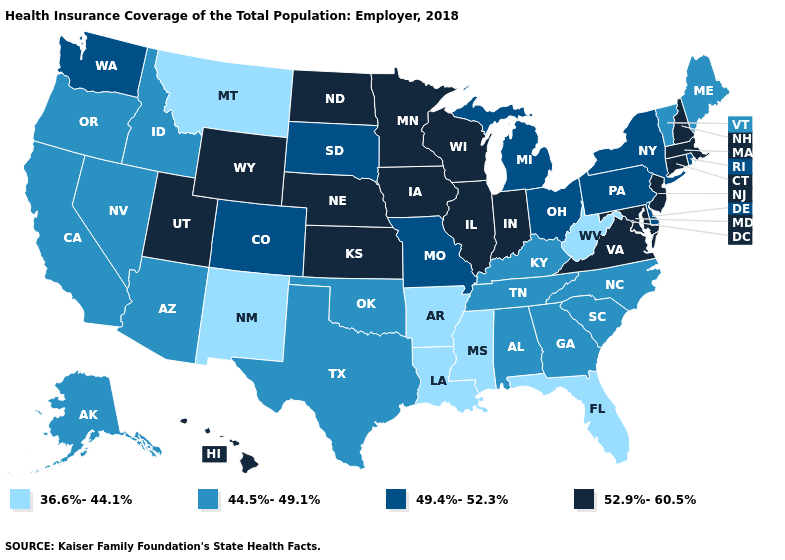Name the states that have a value in the range 52.9%-60.5%?
Short answer required. Connecticut, Hawaii, Illinois, Indiana, Iowa, Kansas, Maryland, Massachusetts, Minnesota, Nebraska, New Hampshire, New Jersey, North Dakota, Utah, Virginia, Wisconsin, Wyoming. Name the states that have a value in the range 49.4%-52.3%?
Give a very brief answer. Colorado, Delaware, Michigan, Missouri, New York, Ohio, Pennsylvania, Rhode Island, South Dakota, Washington. What is the lowest value in the USA?
Concise answer only. 36.6%-44.1%. Does the first symbol in the legend represent the smallest category?
Quick response, please. Yes. Which states have the highest value in the USA?
Write a very short answer. Connecticut, Hawaii, Illinois, Indiana, Iowa, Kansas, Maryland, Massachusetts, Minnesota, Nebraska, New Hampshire, New Jersey, North Dakota, Utah, Virginia, Wisconsin, Wyoming. What is the lowest value in the USA?
Keep it brief. 36.6%-44.1%. Does the map have missing data?
Write a very short answer. No. What is the value of New York?
Give a very brief answer. 49.4%-52.3%. Name the states that have a value in the range 49.4%-52.3%?
Keep it brief. Colorado, Delaware, Michigan, Missouri, New York, Ohio, Pennsylvania, Rhode Island, South Dakota, Washington. Does Iowa have a higher value than Alaska?
Concise answer only. Yes. What is the value of New Mexico?
Answer briefly. 36.6%-44.1%. What is the lowest value in the USA?
Concise answer only. 36.6%-44.1%. Which states hav the highest value in the West?
Keep it brief. Hawaii, Utah, Wyoming. What is the lowest value in the USA?
Concise answer only. 36.6%-44.1%. What is the lowest value in the USA?
Write a very short answer. 36.6%-44.1%. 